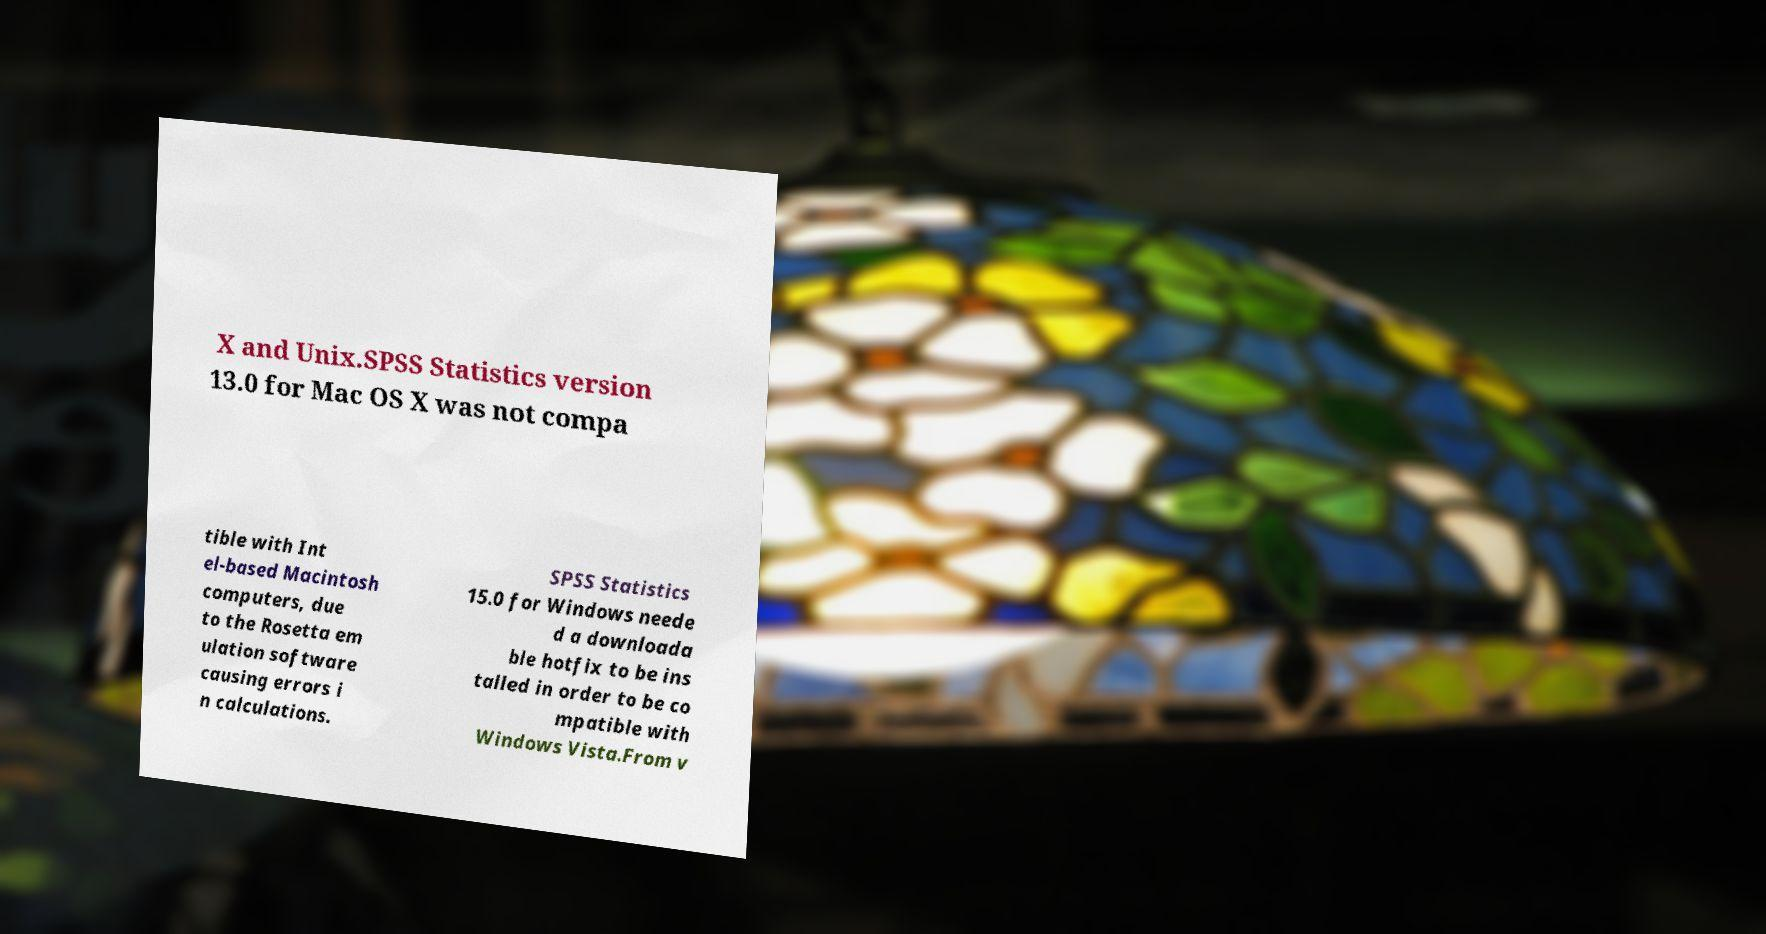Please identify and transcribe the text found in this image. X and Unix.SPSS Statistics version 13.0 for Mac OS X was not compa tible with Int el-based Macintosh computers, due to the Rosetta em ulation software causing errors i n calculations. SPSS Statistics 15.0 for Windows neede d a downloada ble hotfix to be ins talled in order to be co mpatible with Windows Vista.From v 